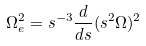<formula> <loc_0><loc_0><loc_500><loc_500>\Omega _ { e } ^ { 2 } = s ^ { - 3 } \frac { d } { d s } ( s ^ { 2 } \Omega ) ^ { 2 }</formula> 